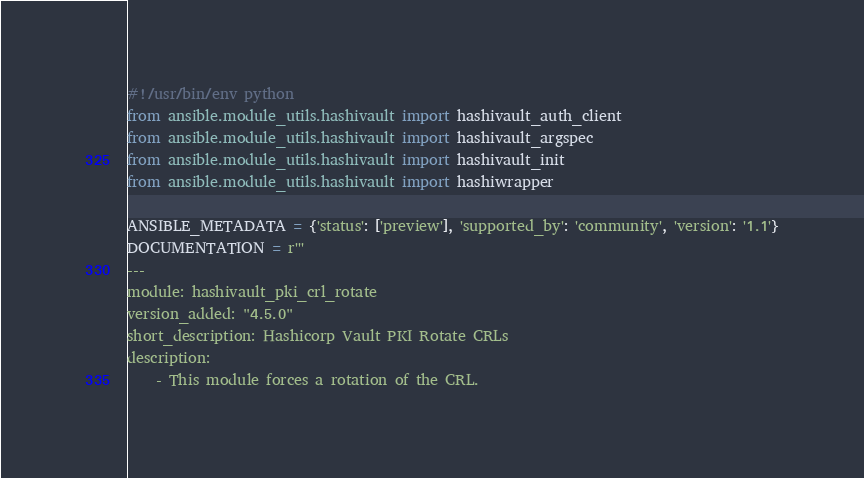Convert code to text. <code><loc_0><loc_0><loc_500><loc_500><_Python_>#!/usr/bin/env python
from ansible.module_utils.hashivault import hashivault_auth_client
from ansible.module_utils.hashivault import hashivault_argspec
from ansible.module_utils.hashivault import hashivault_init
from ansible.module_utils.hashivault import hashiwrapper

ANSIBLE_METADATA = {'status': ['preview'], 'supported_by': 'community', 'version': '1.1'}
DOCUMENTATION = r'''
---
module: hashivault_pki_crl_rotate
version_added: "4.5.0"
short_description: Hashicorp Vault PKI Rotate CRLs
description:
    - This module forces a rotation of the CRL.</code> 